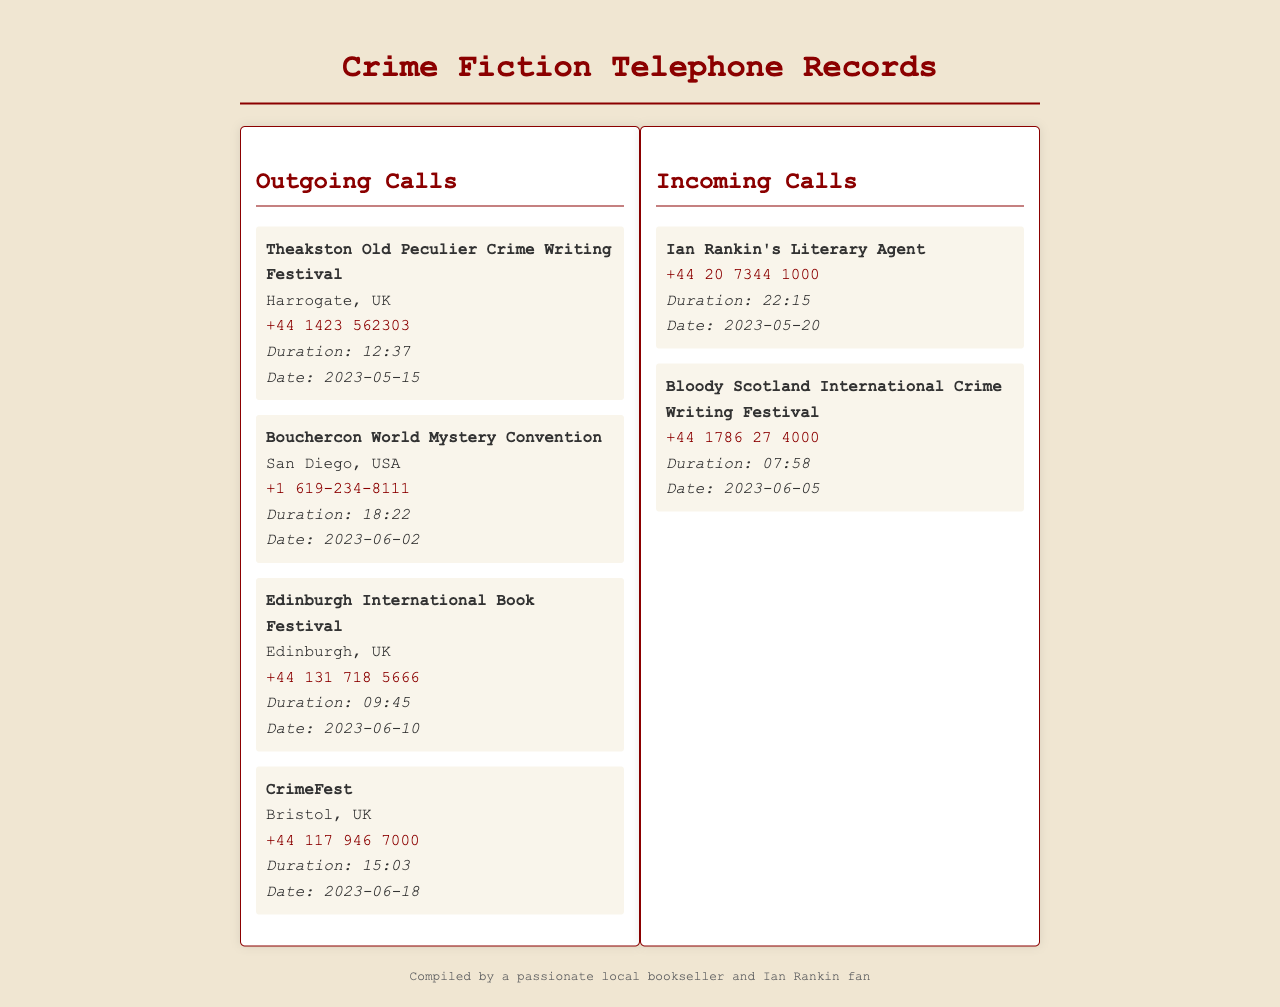What is the location of the Theakston Old Peculier Crime Writing Festival? The location of the festival is specified in the records, which is Harrogate, UK.
Answer: Harrogate, UK What is the phone number for the Bouchercon World Mystery Convention? The phone number is provided in the outgoing calls section, which is +1 619-234-8111.
Answer: +1 619-234-8111 What is the duration of the call from Ian Rankin's Literary Agent? The duration of the call is indicated in the incoming calls section, which is 22:15.
Answer: 22:15 How many outgoing calls are recorded? The number of outgoing calls can be counted from the document, which lists four entries.
Answer: 4 What date was the call to Edinburgh International Book Festival made? The date is explicitly mentioned in the outgoing calls section, which is 2023-06-10.
Answer: 2023-06-10 Who called from the Bloody Scotland International Crime Writing Festival? The caller's name is found in the incoming calls section, which is Bloody Scotland International Crime Writing Festival.
Answer: Bloody Scotland International Crime Writing Festival What is the total duration of all outgoing calls? The total duration can be calculated by adding all provided durations in the outgoing section: 12:37 + 18:22 + 09:45 + 15:03.
Answer: 55:47 What kind of document is presented? The document consists of telephone records detailing calls related to crime fiction events.
Answer: Telephone records 